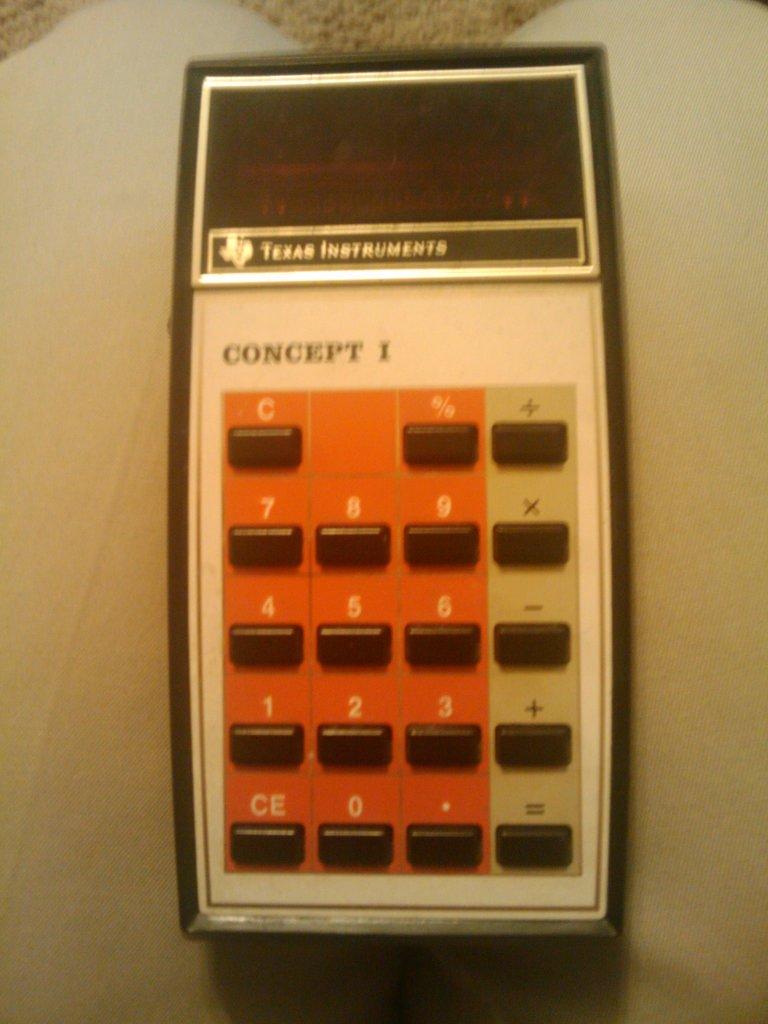Is there a c button?
Give a very brief answer. Yes. What state is in the brand of this?
Make the answer very short. Texas. 